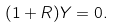<formula> <loc_0><loc_0><loc_500><loc_500>( 1 + R ) Y = 0 .</formula> 